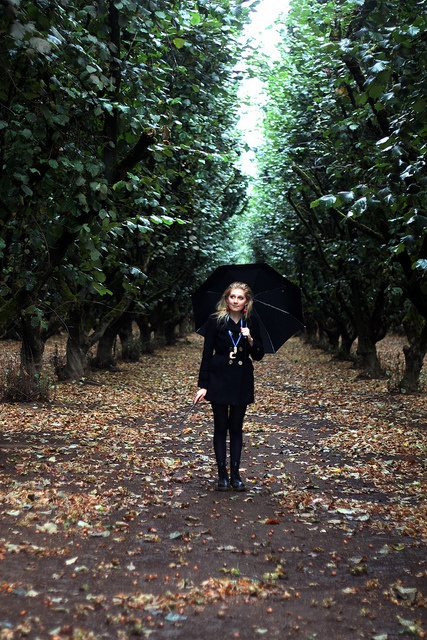Describe the objects in this image and their specific colors. I can see people in black, gray, and white tones and umbrella in black, purple, teal, and darkblue tones in this image. 